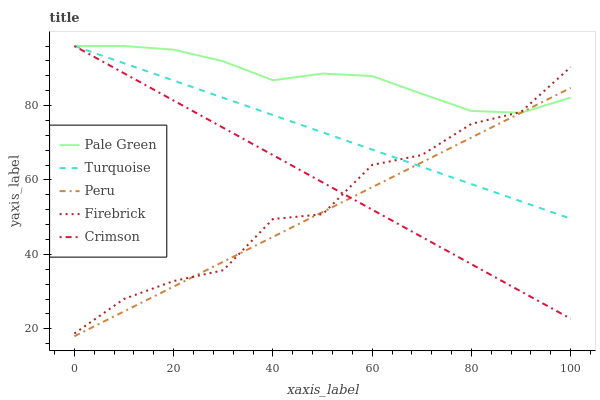Does Peru have the minimum area under the curve?
Answer yes or no. Yes. Does Pale Green have the maximum area under the curve?
Answer yes or no. Yes. Does Turquoise have the minimum area under the curve?
Answer yes or no. No. Does Turquoise have the maximum area under the curve?
Answer yes or no. No. Is Turquoise the smoothest?
Answer yes or no. Yes. Is Firebrick the roughest?
Answer yes or no. Yes. Is Pale Green the smoothest?
Answer yes or no. No. Is Pale Green the roughest?
Answer yes or no. No. Does Peru have the lowest value?
Answer yes or no. Yes. Does Turquoise have the lowest value?
Answer yes or no. No. Does Pale Green have the highest value?
Answer yes or no. Yes. Does Firebrick have the highest value?
Answer yes or no. No. Does Peru intersect Firebrick?
Answer yes or no. Yes. Is Peru less than Firebrick?
Answer yes or no. No. Is Peru greater than Firebrick?
Answer yes or no. No. 